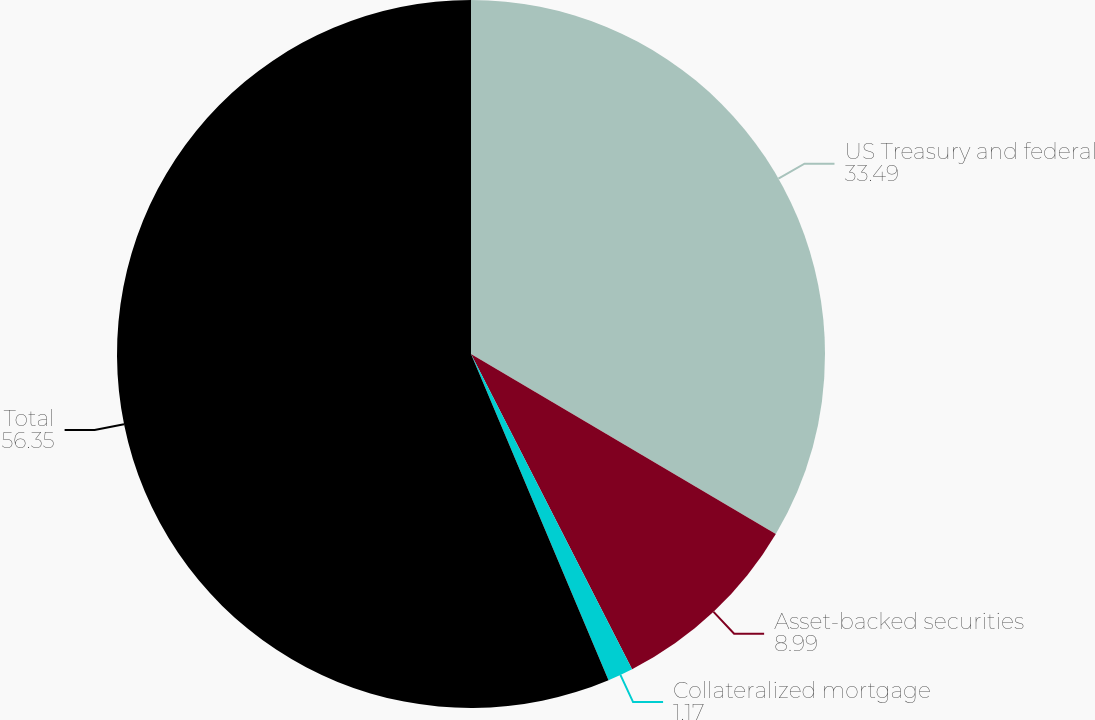Convert chart. <chart><loc_0><loc_0><loc_500><loc_500><pie_chart><fcel>US Treasury and federal<fcel>Asset-backed securities<fcel>Collateralized mortgage<fcel>Total<nl><fcel>33.49%<fcel>8.99%<fcel>1.17%<fcel>56.35%<nl></chart> 